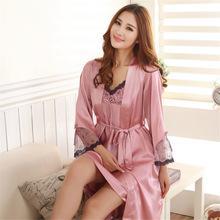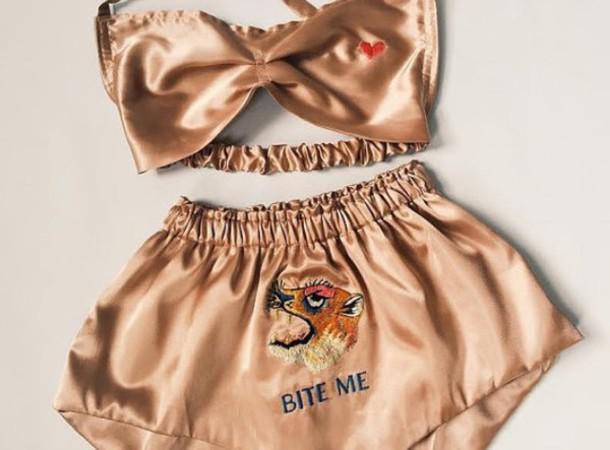The first image is the image on the left, the second image is the image on the right. Analyze the images presented: Is the assertion "There is a woman facing right in the left image." valid? Answer yes or no. No. The first image is the image on the left, the second image is the image on the right. Examine the images to the left and right. Is the description "The girl on the left is wearing a pink set of sleepwear." accurate? Answer yes or no. Yes. 